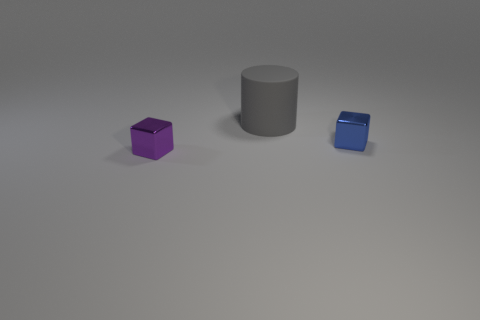What is the color of the cube that is right of the metal object to the left of the small cube that is right of the big object?
Provide a short and direct response. Blue. Are there any tiny red objects that have the same shape as the large rubber thing?
Provide a short and direct response. No. What number of purple shiny things are there?
Provide a succinct answer. 1. What shape is the big object?
Provide a short and direct response. Cylinder. How many blue objects have the same size as the purple cube?
Make the answer very short. 1. Is the gray rubber thing the same shape as the blue shiny object?
Keep it short and to the point. No. There is a shiny object in front of the shiny thing that is on the right side of the big gray matte object; what is its color?
Keep it short and to the point. Purple. What is the size of the thing that is in front of the large gray cylinder and behind the purple object?
Your answer should be compact. Small. Is there anything else of the same color as the large rubber cylinder?
Keep it short and to the point. No. What is the shape of the purple thing that is made of the same material as the small blue thing?
Keep it short and to the point. Cube. 